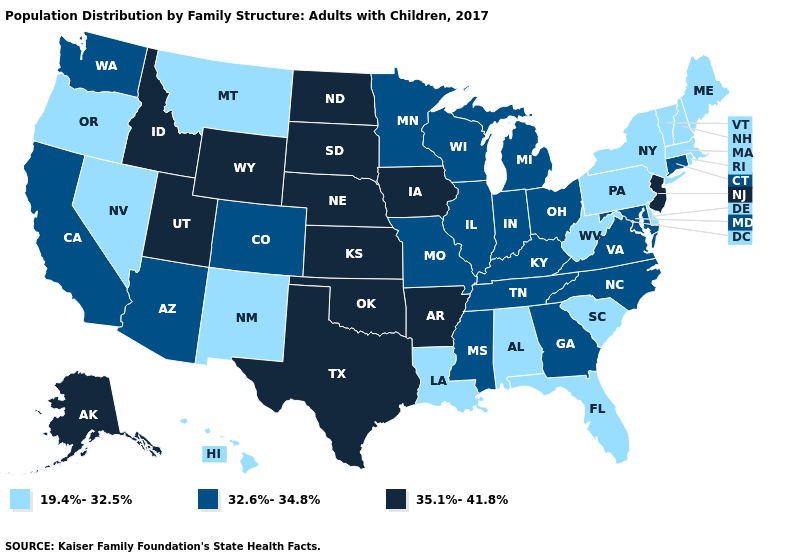What is the value of Texas?
Give a very brief answer. 35.1%-41.8%. Name the states that have a value in the range 19.4%-32.5%?
Concise answer only. Alabama, Delaware, Florida, Hawaii, Louisiana, Maine, Massachusetts, Montana, Nevada, New Hampshire, New Mexico, New York, Oregon, Pennsylvania, Rhode Island, South Carolina, Vermont, West Virginia. Name the states that have a value in the range 19.4%-32.5%?
Give a very brief answer. Alabama, Delaware, Florida, Hawaii, Louisiana, Maine, Massachusetts, Montana, Nevada, New Hampshire, New Mexico, New York, Oregon, Pennsylvania, Rhode Island, South Carolina, Vermont, West Virginia. Among the states that border Washington , which have the lowest value?
Answer briefly. Oregon. Name the states that have a value in the range 19.4%-32.5%?
Keep it brief. Alabama, Delaware, Florida, Hawaii, Louisiana, Maine, Massachusetts, Montana, Nevada, New Hampshire, New Mexico, New York, Oregon, Pennsylvania, Rhode Island, South Carolina, Vermont, West Virginia. Is the legend a continuous bar?
Concise answer only. No. Name the states that have a value in the range 19.4%-32.5%?
Quick response, please. Alabama, Delaware, Florida, Hawaii, Louisiana, Maine, Massachusetts, Montana, Nevada, New Hampshire, New Mexico, New York, Oregon, Pennsylvania, Rhode Island, South Carolina, Vermont, West Virginia. Name the states that have a value in the range 32.6%-34.8%?
Quick response, please. Arizona, California, Colorado, Connecticut, Georgia, Illinois, Indiana, Kentucky, Maryland, Michigan, Minnesota, Mississippi, Missouri, North Carolina, Ohio, Tennessee, Virginia, Washington, Wisconsin. Name the states that have a value in the range 35.1%-41.8%?
Short answer required. Alaska, Arkansas, Idaho, Iowa, Kansas, Nebraska, New Jersey, North Dakota, Oklahoma, South Dakota, Texas, Utah, Wyoming. Does the first symbol in the legend represent the smallest category?
Keep it brief. Yes. What is the lowest value in the USA?
Concise answer only. 19.4%-32.5%. Name the states that have a value in the range 35.1%-41.8%?
Keep it brief. Alaska, Arkansas, Idaho, Iowa, Kansas, Nebraska, New Jersey, North Dakota, Oklahoma, South Dakota, Texas, Utah, Wyoming. Name the states that have a value in the range 19.4%-32.5%?
Keep it brief. Alabama, Delaware, Florida, Hawaii, Louisiana, Maine, Massachusetts, Montana, Nevada, New Hampshire, New Mexico, New York, Oregon, Pennsylvania, Rhode Island, South Carolina, Vermont, West Virginia. Name the states that have a value in the range 35.1%-41.8%?
Answer briefly. Alaska, Arkansas, Idaho, Iowa, Kansas, Nebraska, New Jersey, North Dakota, Oklahoma, South Dakota, Texas, Utah, Wyoming. Name the states that have a value in the range 35.1%-41.8%?
Short answer required. Alaska, Arkansas, Idaho, Iowa, Kansas, Nebraska, New Jersey, North Dakota, Oklahoma, South Dakota, Texas, Utah, Wyoming. 